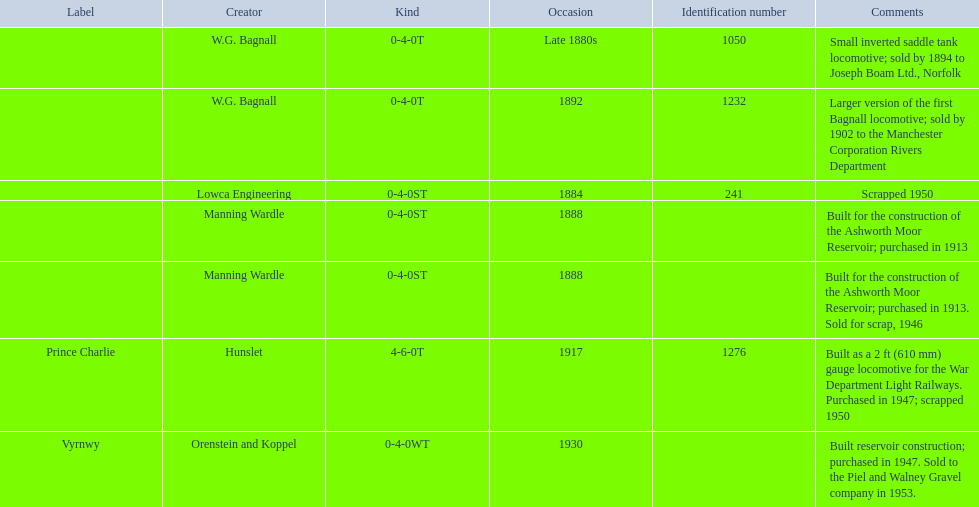Who built the larger version of the first bagnall locomotive? W.G. Bagnall. 